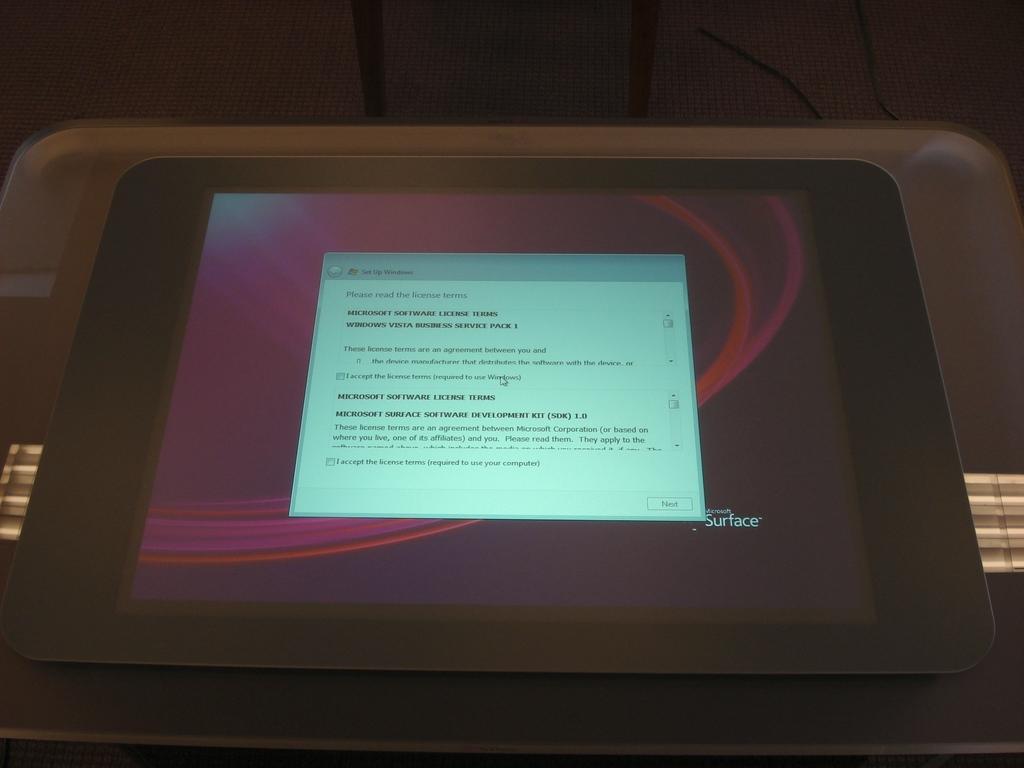In one or two sentences, can you explain what this image depicts? In this image we can see a tablet placed on the table. 